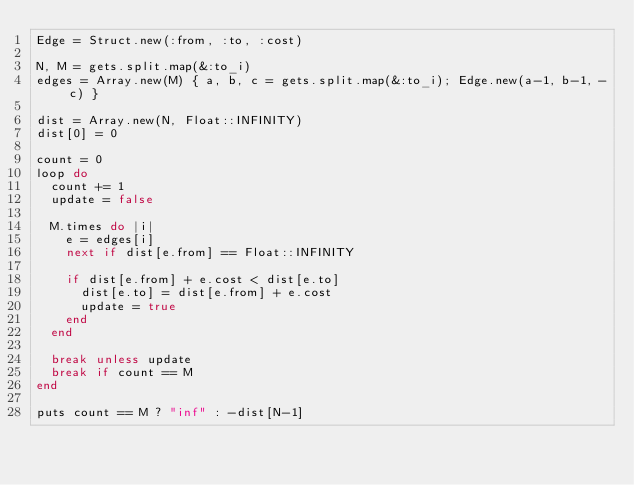Convert code to text. <code><loc_0><loc_0><loc_500><loc_500><_Ruby_>Edge = Struct.new(:from, :to, :cost)

N, M = gets.split.map(&:to_i)
edges = Array.new(M) { a, b, c = gets.split.map(&:to_i); Edge.new(a-1, b-1, -c) }

dist = Array.new(N, Float::INFINITY)
dist[0] = 0

count = 0
loop do
  count += 1
  update = false
  
  M.times do |i|
    e = edges[i]
    next if dist[e.from] == Float::INFINITY
    
    if dist[e.from] + e.cost < dist[e.to]
      dist[e.to] = dist[e.from] + e.cost
      update = true
    end
  end
  
  break unless update
  break if count == M
end

puts count == M ? "inf" : -dist[N-1]</code> 